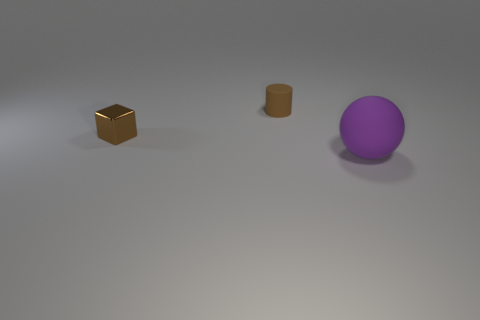Add 1 tiny shiny spheres. How many objects exist? 4 Subtract all cylinders. How many objects are left? 2 Subtract 0 yellow cylinders. How many objects are left? 3 Subtract all big purple metal balls. Subtract all tiny metallic things. How many objects are left? 2 Add 2 tiny blocks. How many tiny blocks are left? 3 Add 3 cylinders. How many cylinders exist? 4 